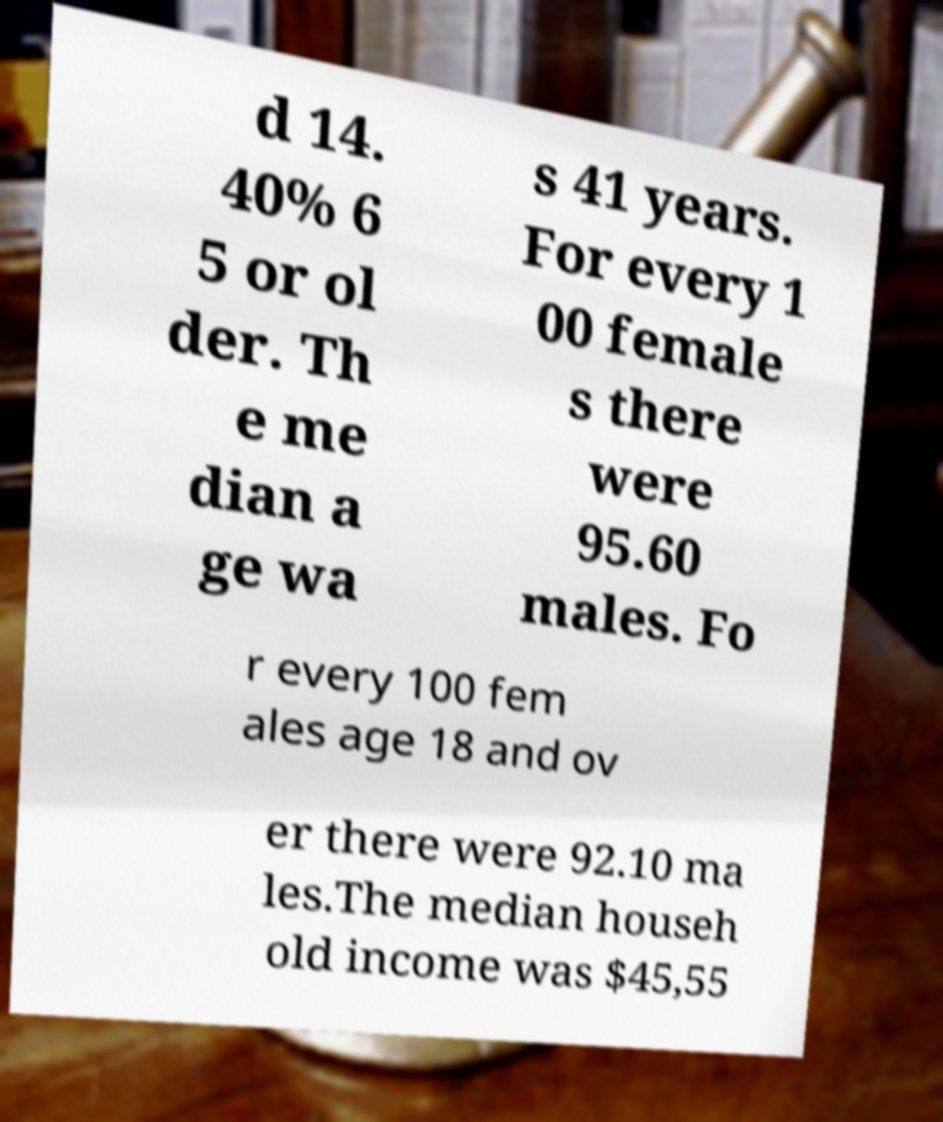Could you assist in decoding the text presented in this image and type it out clearly? d 14. 40% 6 5 or ol der. Th e me dian a ge wa s 41 years. For every 1 00 female s there were 95.60 males. Fo r every 100 fem ales age 18 and ov er there were 92.10 ma les.The median househ old income was $45,55 